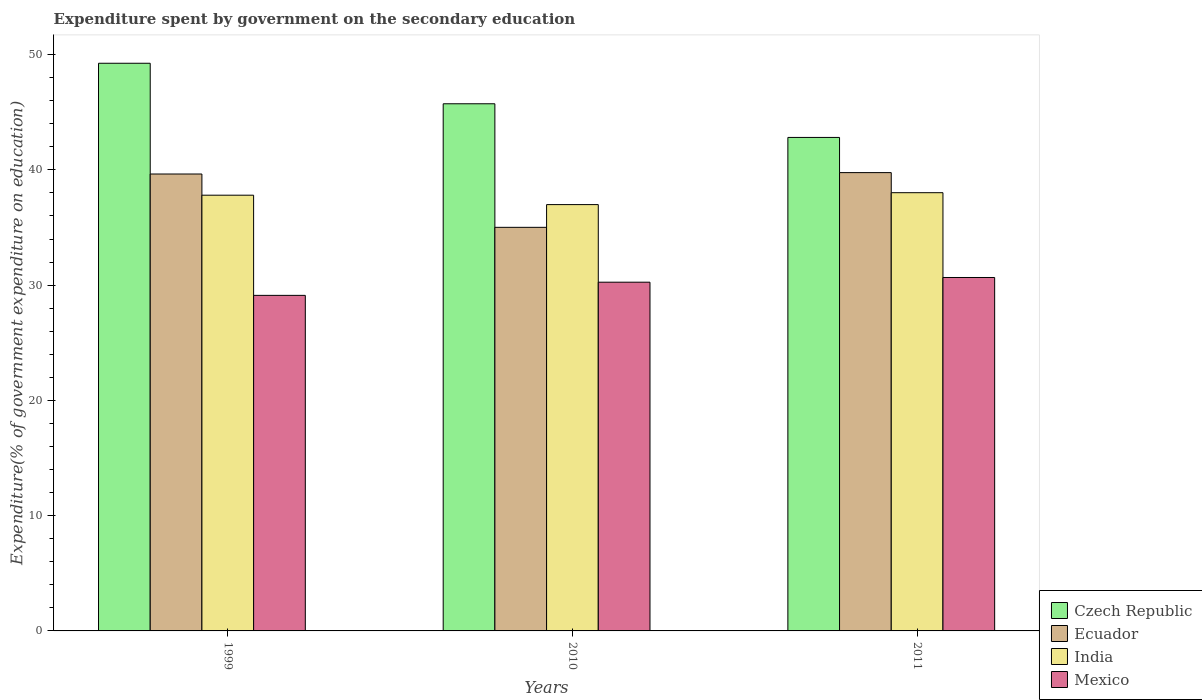How many different coloured bars are there?
Your answer should be very brief. 4. How many groups of bars are there?
Provide a succinct answer. 3. Are the number of bars per tick equal to the number of legend labels?
Provide a succinct answer. Yes. How many bars are there on the 1st tick from the right?
Make the answer very short. 4. What is the expenditure spent by government on the secondary education in India in 2011?
Your answer should be very brief. 38.02. Across all years, what is the maximum expenditure spent by government on the secondary education in Czech Republic?
Offer a very short reply. 49.25. Across all years, what is the minimum expenditure spent by government on the secondary education in India?
Your answer should be very brief. 36.99. In which year was the expenditure spent by government on the secondary education in India maximum?
Make the answer very short. 2011. In which year was the expenditure spent by government on the secondary education in Czech Republic minimum?
Make the answer very short. 2011. What is the total expenditure spent by government on the secondary education in Czech Republic in the graph?
Your response must be concise. 137.79. What is the difference between the expenditure spent by government on the secondary education in Ecuador in 1999 and that in 2011?
Your answer should be very brief. -0.12. What is the difference between the expenditure spent by government on the secondary education in Ecuador in 2010 and the expenditure spent by government on the secondary education in India in 1999?
Give a very brief answer. -2.79. What is the average expenditure spent by government on the secondary education in Czech Republic per year?
Give a very brief answer. 45.93. In the year 2011, what is the difference between the expenditure spent by government on the secondary education in India and expenditure spent by government on the secondary education in Czech Republic?
Offer a very short reply. -4.8. What is the ratio of the expenditure spent by government on the secondary education in India in 2010 to that in 2011?
Keep it short and to the point. 0.97. Is the difference between the expenditure spent by government on the secondary education in India in 2010 and 2011 greater than the difference between the expenditure spent by government on the secondary education in Czech Republic in 2010 and 2011?
Provide a succinct answer. No. What is the difference between the highest and the second highest expenditure spent by government on the secondary education in Czech Republic?
Provide a succinct answer. 3.51. What is the difference between the highest and the lowest expenditure spent by government on the secondary education in Ecuador?
Provide a succinct answer. 4.75. Is it the case that in every year, the sum of the expenditure spent by government on the secondary education in Czech Republic and expenditure spent by government on the secondary education in Ecuador is greater than the sum of expenditure spent by government on the secondary education in Mexico and expenditure spent by government on the secondary education in India?
Ensure brevity in your answer.  No. What does the 3rd bar from the left in 1999 represents?
Your response must be concise. India. What does the 4th bar from the right in 2010 represents?
Ensure brevity in your answer.  Czech Republic. Is it the case that in every year, the sum of the expenditure spent by government on the secondary education in India and expenditure spent by government on the secondary education in Ecuador is greater than the expenditure spent by government on the secondary education in Mexico?
Make the answer very short. Yes. Are all the bars in the graph horizontal?
Provide a succinct answer. No. Are the values on the major ticks of Y-axis written in scientific E-notation?
Provide a succinct answer. No. Where does the legend appear in the graph?
Provide a succinct answer. Bottom right. What is the title of the graph?
Provide a succinct answer. Expenditure spent by government on the secondary education. Does "Belgium" appear as one of the legend labels in the graph?
Keep it short and to the point. No. What is the label or title of the X-axis?
Make the answer very short. Years. What is the label or title of the Y-axis?
Provide a short and direct response. Expenditure(% of government expenditure on education). What is the Expenditure(% of government expenditure on education) in Czech Republic in 1999?
Your answer should be compact. 49.25. What is the Expenditure(% of government expenditure on education) of Ecuador in 1999?
Your answer should be very brief. 39.64. What is the Expenditure(% of government expenditure on education) in India in 1999?
Give a very brief answer. 37.8. What is the Expenditure(% of government expenditure on education) of Mexico in 1999?
Your answer should be very brief. 29.11. What is the Expenditure(% of government expenditure on education) in Czech Republic in 2010?
Provide a succinct answer. 45.73. What is the Expenditure(% of government expenditure on education) of Ecuador in 2010?
Offer a very short reply. 35.01. What is the Expenditure(% of government expenditure on education) of India in 2010?
Keep it short and to the point. 36.99. What is the Expenditure(% of government expenditure on education) in Mexico in 2010?
Offer a terse response. 30.25. What is the Expenditure(% of government expenditure on education) of Czech Republic in 2011?
Your answer should be very brief. 42.81. What is the Expenditure(% of government expenditure on education) of Ecuador in 2011?
Your answer should be very brief. 39.76. What is the Expenditure(% of government expenditure on education) in India in 2011?
Keep it short and to the point. 38.02. What is the Expenditure(% of government expenditure on education) of Mexico in 2011?
Your response must be concise. 30.66. Across all years, what is the maximum Expenditure(% of government expenditure on education) of Czech Republic?
Your answer should be compact. 49.25. Across all years, what is the maximum Expenditure(% of government expenditure on education) in Ecuador?
Keep it short and to the point. 39.76. Across all years, what is the maximum Expenditure(% of government expenditure on education) in India?
Provide a short and direct response. 38.02. Across all years, what is the maximum Expenditure(% of government expenditure on education) of Mexico?
Make the answer very short. 30.66. Across all years, what is the minimum Expenditure(% of government expenditure on education) in Czech Republic?
Your answer should be very brief. 42.81. Across all years, what is the minimum Expenditure(% of government expenditure on education) in Ecuador?
Offer a terse response. 35.01. Across all years, what is the minimum Expenditure(% of government expenditure on education) of India?
Your response must be concise. 36.99. Across all years, what is the minimum Expenditure(% of government expenditure on education) of Mexico?
Give a very brief answer. 29.11. What is the total Expenditure(% of government expenditure on education) in Czech Republic in the graph?
Give a very brief answer. 137.79. What is the total Expenditure(% of government expenditure on education) in Ecuador in the graph?
Offer a very short reply. 114.41. What is the total Expenditure(% of government expenditure on education) in India in the graph?
Offer a very short reply. 112.81. What is the total Expenditure(% of government expenditure on education) in Mexico in the graph?
Your response must be concise. 90.03. What is the difference between the Expenditure(% of government expenditure on education) of Czech Republic in 1999 and that in 2010?
Make the answer very short. 3.51. What is the difference between the Expenditure(% of government expenditure on education) in Ecuador in 1999 and that in 2010?
Offer a terse response. 4.63. What is the difference between the Expenditure(% of government expenditure on education) of India in 1999 and that in 2010?
Your answer should be very brief. 0.82. What is the difference between the Expenditure(% of government expenditure on education) in Mexico in 1999 and that in 2010?
Make the answer very short. -1.14. What is the difference between the Expenditure(% of government expenditure on education) of Czech Republic in 1999 and that in 2011?
Offer a terse response. 6.43. What is the difference between the Expenditure(% of government expenditure on education) in Ecuador in 1999 and that in 2011?
Provide a succinct answer. -0.12. What is the difference between the Expenditure(% of government expenditure on education) in India in 1999 and that in 2011?
Provide a succinct answer. -0.22. What is the difference between the Expenditure(% of government expenditure on education) in Mexico in 1999 and that in 2011?
Make the answer very short. -1.55. What is the difference between the Expenditure(% of government expenditure on education) of Czech Republic in 2010 and that in 2011?
Provide a succinct answer. 2.92. What is the difference between the Expenditure(% of government expenditure on education) of Ecuador in 2010 and that in 2011?
Ensure brevity in your answer.  -4.75. What is the difference between the Expenditure(% of government expenditure on education) of India in 2010 and that in 2011?
Provide a short and direct response. -1.03. What is the difference between the Expenditure(% of government expenditure on education) of Mexico in 2010 and that in 2011?
Your answer should be compact. -0.41. What is the difference between the Expenditure(% of government expenditure on education) of Czech Republic in 1999 and the Expenditure(% of government expenditure on education) of Ecuador in 2010?
Provide a short and direct response. 14.23. What is the difference between the Expenditure(% of government expenditure on education) of Czech Republic in 1999 and the Expenditure(% of government expenditure on education) of India in 2010?
Your response must be concise. 12.26. What is the difference between the Expenditure(% of government expenditure on education) of Czech Republic in 1999 and the Expenditure(% of government expenditure on education) of Mexico in 2010?
Your response must be concise. 18.99. What is the difference between the Expenditure(% of government expenditure on education) of Ecuador in 1999 and the Expenditure(% of government expenditure on education) of India in 2010?
Ensure brevity in your answer.  2.66. What is the difference between the Expenditure(% of government expenditure on education) of Ecuador in 1999 and the Expenditure(% of government expenditure on education) of Mexico in 2010?
Make the answer very short. 9.39. What is the difference between the Expenditure(% of government expenditure on education) of India in 1999 and the Expenditure(% of government expenditure on education) of Mexico in 2010?
Provide a succinct answer. 7.55. What is the difference between the Expenditure(% of government expenditure on education) of Czech Republic in 1999 and the Expenditure(% of government expenditure on education) of Ecuador in 2011?
Ensure brevity in your answer.  9.49. What is the difference between the Expenditure(% of government expenditure on education) in Czech Republic in 1999 and the Expenditure(% of government expenditure on education) in India in 2011?
Provide a short and direct response. 11.23. What is the difference between the Expenditure(% of government expenditure on education) in Czech Republic in 1999 and the Expenditure(% of government expenditure on education) in Mexico in 2011?
Give a very brief answer. 18.59. What is the difference between the Expenditure(% of government expenditure on education) of Ecuador in 1999 and the Expenditure(% of government expenditure on education) of India in 2011?
Your response must be concise. 1.62. What is the difference between the Expenditure(% of government expenditure on education) of Ecuador in 1999 and the Expenditure(% of government expenditure on education) of Mexico in 2011?
Make the answer very short. 8.98. What is the difference between the Expenditure(% of government expenditure on education) of India in 1999 and the Expenditure(% of government expenditure on education) of Mexico in 2011?
Your response must be concise. 7.14. What is the difference between the Expenditure(% of government expenditure on education) in Czech Republic in 2010 and the Expenditure(% of government expenditure on education) in Ecuador in 2011?
Provide a short and direct response. 5.97. What is the difference between the Expenditure(% of government expenditure on education) of Czech Republic in 2010 and the Expenditure(% of government expenditure on education) of India in 2011?
Offer a terse response. 7.72. What is the difference between the Expenditure(% of government expenditure on education) in Czech Republic in 2010 and the Expenditure(% of government expenditure on education) in Mexico in 2011?
Provide a succinct answer. 15.07. What is the difference between the Expenditure(% of government expenditure on education) in Ecuador in 2010 and the Expenditure(% of government expenditure on education) in India in 2011?
Offer a very short reply. -3. What is the difference between the Expenditure(% of government expenditure on education) of Ecuador in 2010 and the Expenditure(% of government expenditure on education) of Mexico in 2011?
Your answer should be compact. 4.35. What is the difference between the Expenditure(% of government expenditure on education) of India in 2010 and the Expenditure(% of government expenditure on education) of Mexico in 2011?
Make the answer very short. 6.32. What is the average Expenditure(% of government expenditure on education) of Czech Republic per year?
Your answer should be compact. 45.93. What is the average Expenditure(% of government expenditure on education) in Ecuador per year?
Give a very brief answer. 38.14. What is the average Expenditure(% of government expenditure on education) in India per year?
Provide a short and direct response. 37.6. What is the average Expenditure(% of government expenditure on education) of Mexico per year?
Ensure brevity in your answer.  30.01. In the year 1999, what is the difference between the Expenditure(% of government expenditure on education) in Czech Republic and Expenditure(% of government expenditure on education) in Ecuador?
Your answer should be very brief. 9.61. In the year 1999, what is the difference between the Expenditure(% of government expenditure on education) in Czech Republic and Expenditure(% of government expenditure on education) in India?
Your answer should be compact. 11.45. In the year 1999, what is the difference between the Expenditure(% of government expenditure on education) of Czech Republic and Expenditure(% of government expenditure on education) of Mexico?
Offer a very short reply. 20.14. In the year 1999, what is the difference between the Expenditure(% of government expenditure on education) of Ecuador and Expenditure(% of government expenditure on education) of India?
Your answer should be very brief. 1.84. In the year 1999, what is the difference between the Expenditure(% of government expenditure on education) in Ecuador and Expenditure(% of government expenditure on education) in Mexico?
Your answer should be compact. 10.53. In the year 1999, what is the difference between the Expenditure(% of government expenditure on education) in India and Expenditure(% of government expenditure on education) in Mexico?
Your response must be concise. 8.69. In the year 2010, what is the difference between the Expenditure(% of government expenditure on education) of Czech Republic and Expenditure(% of government expenditure on education) of Ecuador?
Your response must be concise. 10.72. In the year 2010, what is the difference between the Expenditure(% of government expenditure on education) of Czech Republic and Expenditure(% of government expenditure on education) of India?
Give a very brief answer. 8.75. In the year 2010, what is the difference between the Expenditure(% of government expenditure on education) in Czech Republic and Expenditure(% of government expenditure on education) in Mexico?
Offer a very short reply. 15.48. In the year 2010, what is the difference between the Expenditure(% of government expenditure on education) of Ecuador and Expenditure(% of government expenditure on education) of India?
Your answer should be compact. -1.97. In the year 2010, what is the difference between the Expenditure(% of government expenditure on education) of Ecuador and Expenditure(% of government expenditure on education) of Mexico?
Offer a terse response. 4.76. In the year 2010, what is the difference between the Expenditure(% of government expenditure on education) of India and Expenditure(% of government expenditure on education) of Mexico?
Ensure brevity in your answer.  6.73. In the year 2011, what is the difference between the Expenditure(% of government expenditure on education) of Czech Republic and Expenditure(% of government expenditure on education) of Ecuador?
Offer a terse response. 3.05. In the year 2011, what is the difference between the Expenditure(% of government expenditure on education) of Czech Republic and Expenditure(% of government expenditure on education) of India?
Make the answer very short. 4.8. In the year 2011, what is the difference between the Expenditure(% of government expenditure on education) in Czech Republic and Expenditure(% of government expenditure on education) in Mexico?
Provide a succinct answer. 12.15. In the year 2011, what is the difference between the Expenditure(% of government expenditure on education) of Ecuador and Expenditure(% of government expenditure on education) of India?
Your response must be concise. 1.74. In the year 2011, what is the difference between the Expenditure(% of government expenditure on education) of Ecuador and Expenditure(% of government expenditure on education) of Mexico?
Your answer should be very brief. 9.1. In the year 2011, what is the difference between the Expenditure(% of government expenditure on education) in India and Expenditure(% of government expenditure on education) in Mexico?
Offer a terse response. 7.36. What is the ratio of the Expenditure(% of government expenditure on education) in Czech Republic in 1999 to that in 2010?
Ensure brevity in your answer.  1.08. What is the ratio of the Expenditure(% of government expenditure on education) of Ecuador in 1999 to that in 2010?
Offer a terse response. 1.13. What is the ratio of the Expenditure(% of government expenditure on education) of India in 1999 to that in 2010?
Ensure brevity in your answer.  1.02. What is the ratio of the Expenditure(% of government expenditure on education) in Mexico in 1999 to that in 2010?
Keep it short and to the point. 0.96. What is the ratio of the Expenditure(% of government expenditure on education) of Czech Republic in 1999 to that in 2011?
Make the answer very short. 1.15. What is the ratio of the Expenditure(% of government expenditure on education) in Mexico in 1999 to that in 2011?
Provide a short and direct response. 0.95. What is the ratio of the Expenditure(% of government expenditure on education) in Czech Republic in 2010 to that in 2011?
Provide a short and direct response. 1.07. What is the ratio of the Expenditure(% of government expenditure on education) in Ecuador in 2010 to that in 2011?
Your response must be concise. 0.88. What is the ratio of the Expenditure(% of government expenditure on education) of India in 2010 to that in 2011?
Ensure brevity in your answer.  0.97. What is the ratio of the Expenditure(% of government expenditure on education) of Mexico in 2010 to that in 2011?
Ensure brevity in your answer.  0.99. What is the difference between the highest and the second highest Expenditure(% of government expenditure on education) of Czech Republic?
Your response must be concise. 3.51. What is the difference between the highest and the second highest Expenditure(% of government expenditure on education) of Ecuador?
Your response must be concise. 0.12. What is the difference between the highest and the second highest Expenditure(% of government expenditure on education) of India?
Offer a very short reply. 0.22. What is the difference between the highest and the second highest Expenditure(% of government expenditure on education) of Mexico?
Your answer should be very brief. 0.41. What is the difference between the highest and the lowest Expenditure(% of government expenditure on education) in Czech Republic?
Offer a terse response. 6.43. What is the difference between the highest and the lowest Expenditure(% of government expenditure on education) of Ecuador?
Your answer should be very brief. 4.75. What is the difference between the highest and the lowest Expenditure(% of government expenditure on education) in India?
Your answer should be compact. 1.03. What is the difference between the highest and the lowest Expenditure(% of government expenditure on education) of Mexico?
Ensure brevity in your answer.  1.55. 